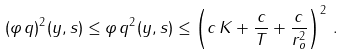<formula> <loc_0><loc_0><loc_500><loc_500>( \varphi \, q ) ^ { 2 } ( y , s ) \leq \varphi \, q ^ { 2 } ( y , s ) \leq \left ( c \, K + \frac { c } { T } + \frac { c } { r _ { o } ^ { 2 } } \right ) ^ { 2 } \, .</formula> 